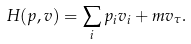Convert formula to latex. <formula><loc_0><loc_0><loc_500><loc_500>H ( p , v ) = \sum _ { i } p _ { i } v _ { i } + m v _ { \tau } .</formula> 